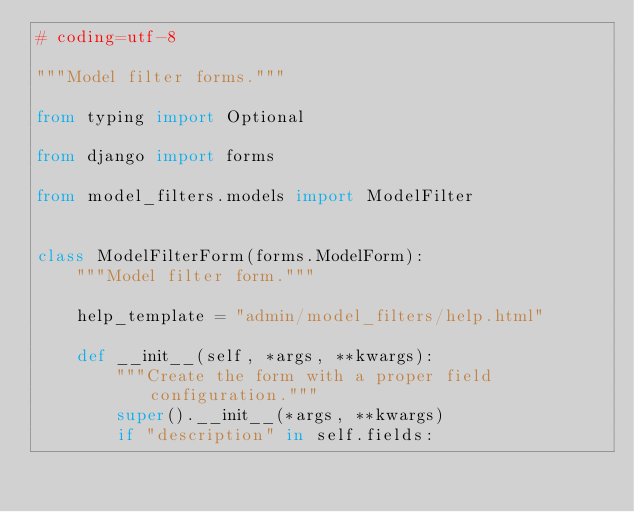Convert code to text. <code><loc_0><loc_0><loc_500><loc_500><_Python_># coding=utf-8

"""Model filter forms."""

from typing import Optional

from django import forms

from model_filters.models import ModelFilter


class ModelFilterForm(forms.ModelForm):
    """Model filter form."""

    help_template = "admin/model_filters/help.html"

    def __init__(self, *args, **kwargs):
        """Create the form with a proper field configuration."""
        super().__init__(*args, **kwargs)
        if "description" in self.fields:</code> 